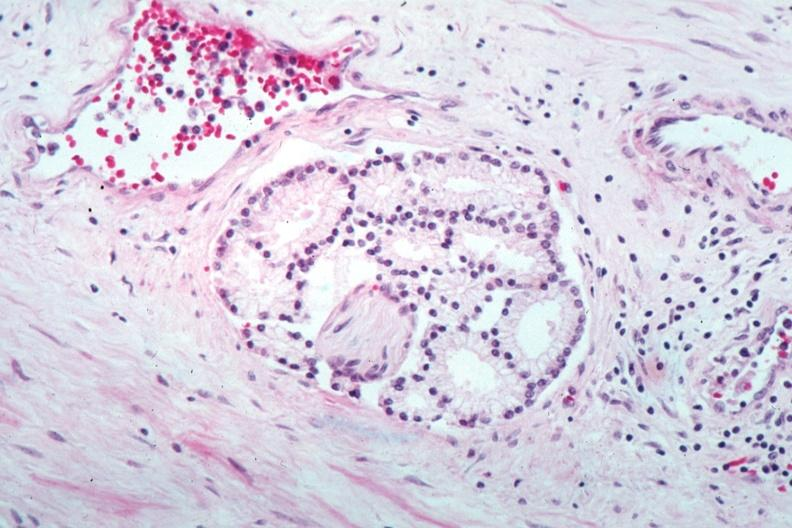what is present?
Answer the question using a single word or phrase. Prostate 